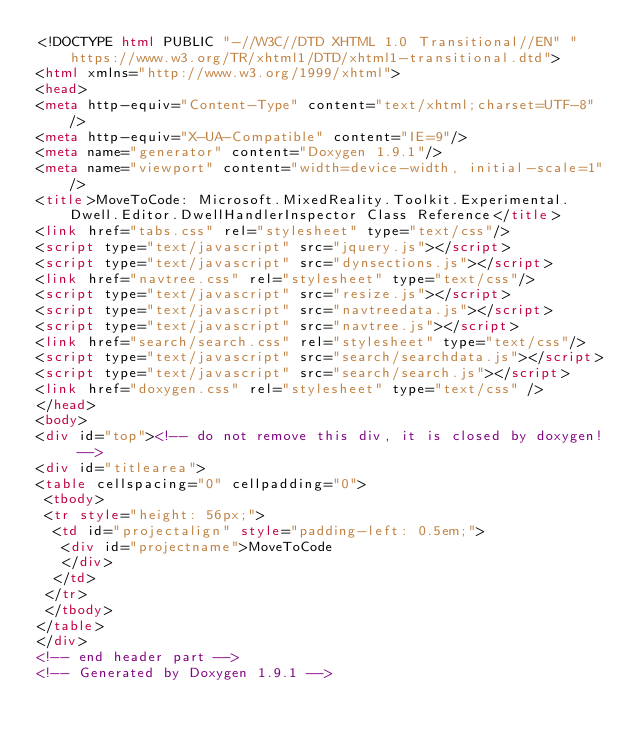Convert code to text. <code><loc_0><loc_0><loc_500><loc_500><_HTML_><!DOCTYPE html PUBLIC "-//W3C//DTD XHTML 1.0 Transitional//EN" "https://www.w3.org/TR/xhtml1/DTD/xhtml1-transitional.dtd">
<html xmlns="http://www.w3.org/1999/xhtml">
<head>
<meta http-equiv="Content-Type" content="text/xhtml;charset=UTF-8"/>
<meta http-equiv="X-UA-Compatible" content="IE=9"/>
<meta name="generator" content="Doxygen 1.9.1"/>
<meta name="viewport" content="width=device-width, initial-scale=1"/>
<title>MoveToCode: Microsoft.MixedReality.Toolkit.Experimental.Dwell.Editor.DwellHandlerInspector Class Reference</title>
<link href="tabs.css" rel="stylesheet" type="text/css"/>
<script type="text/javascript" src="jquery.js"></script>
<script type="text/javascript" src="dynsections.js"></script>
<link href="navtree.css" rel="stylesheet" type="text/css"/>
<script type="text/javascript" src="resize.js"></script>
<script type="text/javascript" src="navtreedata.js"></script>
<script type="text/javascript" src="navtree.js"></script>
<link href="search/search.css" rel="stylesheet" type="text/css"/>
<script type="text/javascript" src="search/searchdata.js"></script>
<script type="text/javascript" src="search/search.js"></script>
<link href="doxygen.css" rel="stylesheet" type="text/css" />
</head>
<body>
<div id="top"><!-- do not remove this div, it is closed by doxygen! -->
<div id="titlearea">
<table cellspacing="0" cellpadding="0">
 <tbody>
 <tr style="height: 56px;">
  <td id="projectalign" style="padding-left: 0.5em;">
   <div id="projectname">MoveToCode
   </div>
  </td>
 </tr>
 </tbody>
</table>
</div>
<!-- end header part -->
<!-- Generated by Doxygen 1.9.1 --></code> 